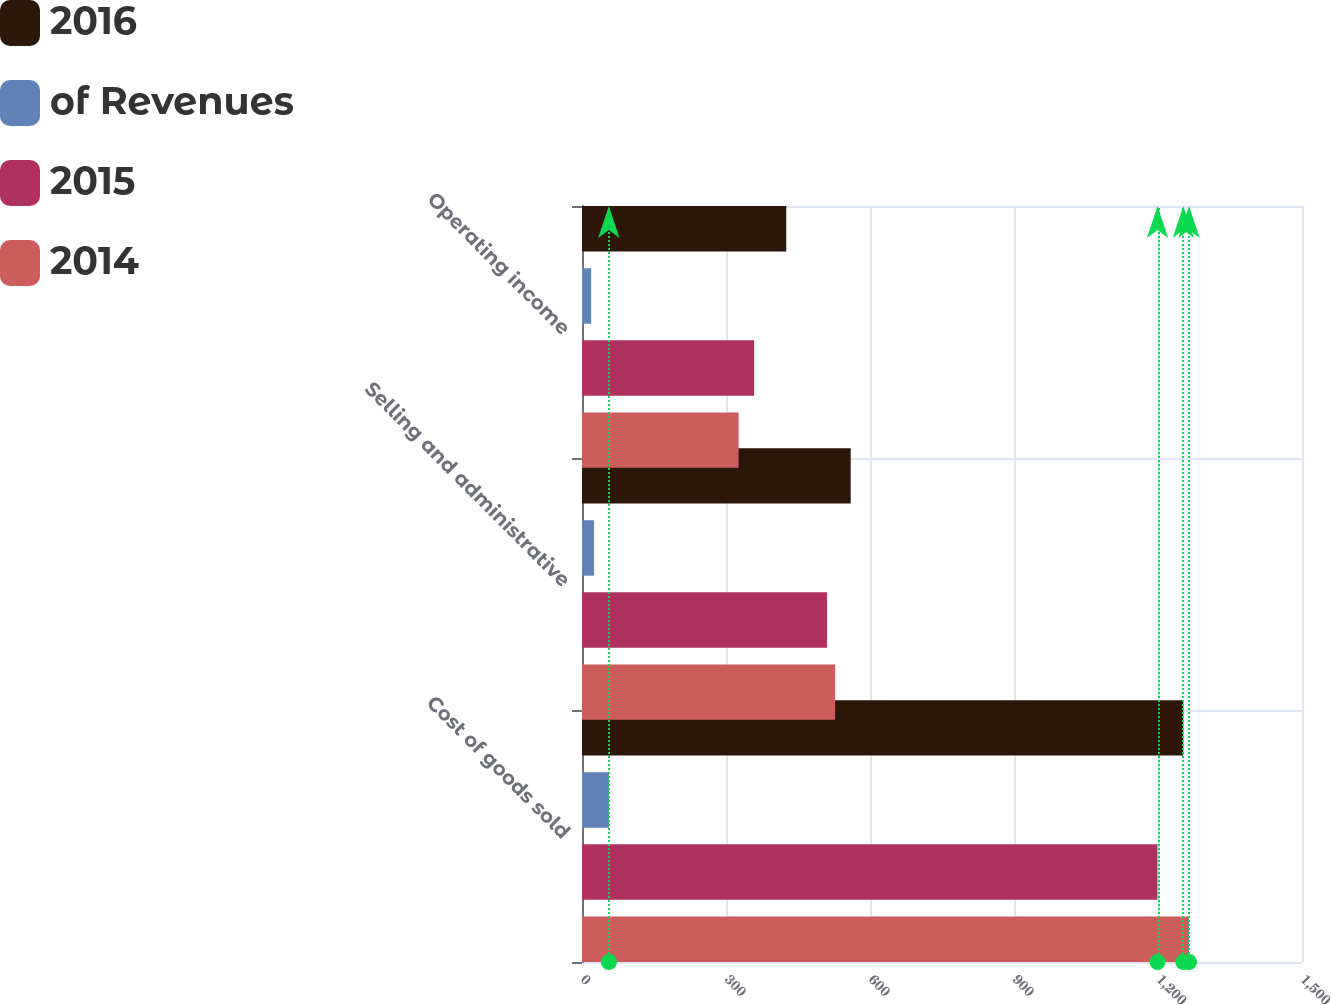<chart> <loc_0><loc_0><loc_500><loc_500><stacked_bar_chart><ecel><fcel>Cost of goods sold<fcel>Selling and administrative<fcel>Operating income<nl><fcel>2016<fcel>1252.7<fcel>559.8<fcel>425.5<nl><fcel>of Revenues<fcel>56<fcel>25<fcel>19<nl><fcel>2015<fcel>1199<fcel>510.5<fcel>358.6<nl><fcel>2014<fcel>1264.6<fcel>527.4<fcel>326.3<nl></chart> 